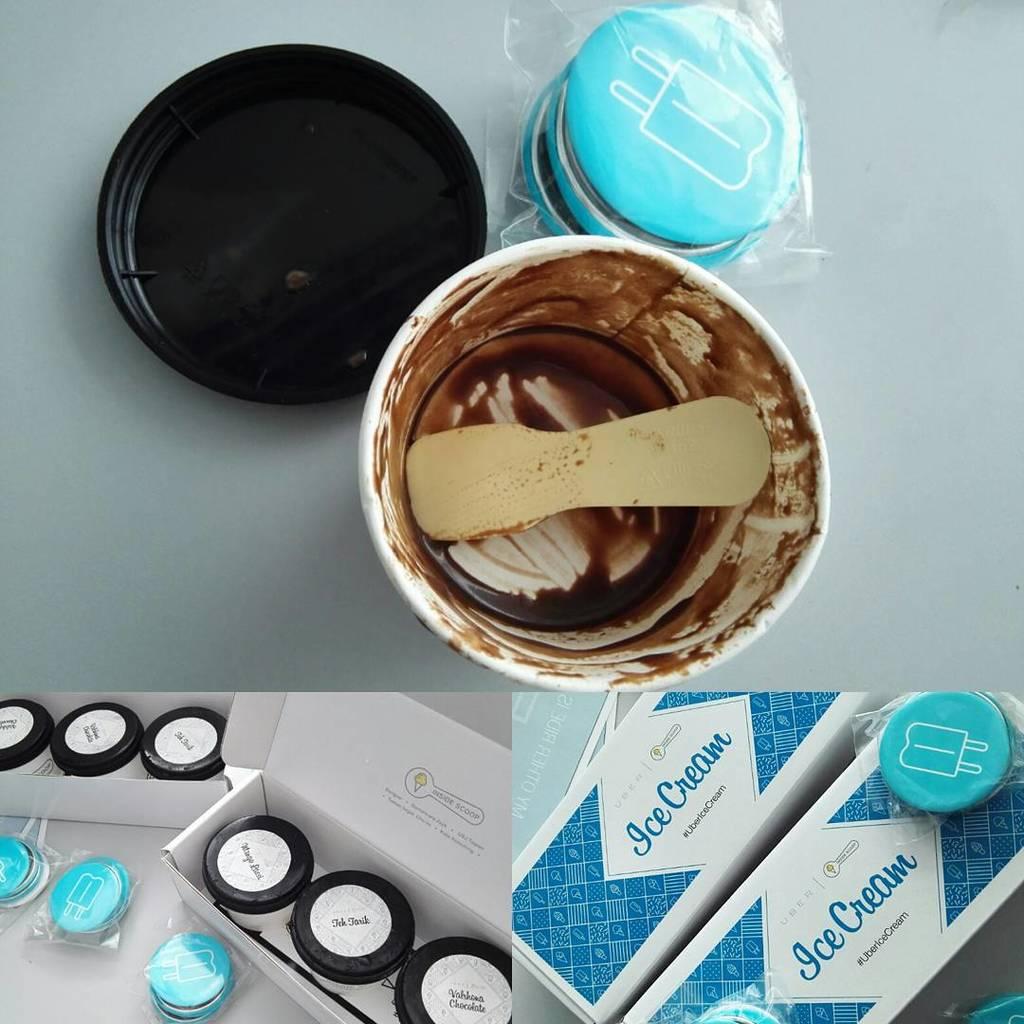What color are the letters on the box?
Your answer should be very brief. Blue. What is on the blue bloxes?
Offer a terse response. Ice cream. 